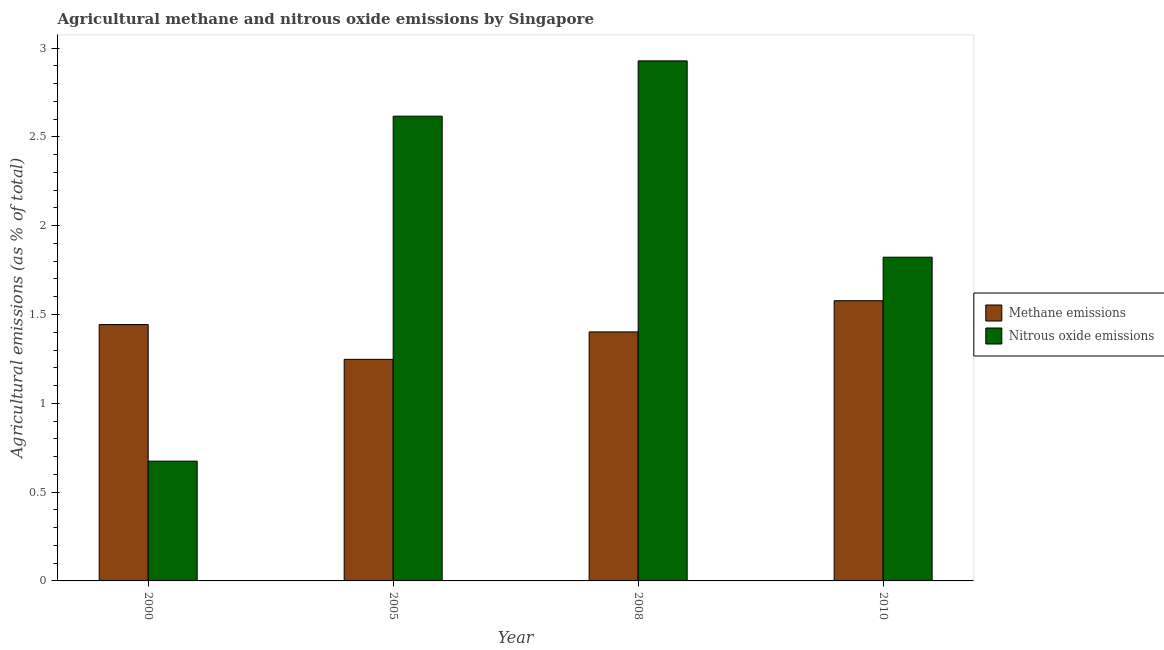How many different coloured bars are there?
Ensure brevity in your answer.  2. Are the number of bars per tick equal to the number of legend labels?
Give a very brief answer. Yes. How many bars are there on the 3rd tick from the right?
Offer a very short reply. 2. What is the label of the 4th group of bars from the left?
Offer a very short reply. 2010. What is the amount of methane emissions in 2000?
Ensure brevity in your answer.  1.44. Across all years, what is the maximum amount of nitrous oxide emissions?
Your answer should be compact. 2.93. Across all years, what is the minimum amount of nitrous oxide emissions?
Make the answer very short. 0.67. In which year was the amount of nitrous oxide emissions maximum?
Ensure brevity in your answer.  2008. What is the total amount of nitrous oxide emissions in the graph?
Give a very brief answer. 8.04. What is the difference between the amount of nitrous oxide emissions in 2008 and that in 2010?
Give a very brief answer. 1.11. What is the difference between the amount of nitrous oxide emissions in 2008 and the amount of methane emissions in 2010?
Ensure brevity in your answer.  1.11. What is the average amount of nitrous oxide emissions per year?
Offer a very short reply. 2.01. In the year 2000, what is the difference between the amount of methane emissions and amount of nitrous oxide emissions?
Offer a very short reply. 0. In how many years, is the amount of nitrous oxide emissions greater than 0.8 %?
Ensure brevity in your answer.  3. What is the ratio of the amount of methane emissions in 2005 to that in 2010?
Offer a terse response. 0.79. Is the difference between the amount of methane emissions in 2000 and 2005 greater than the difference between the amount of nitrous oxide emissions in 2000 and 2005?
Your answer should be very brief. No. What is the difference between the highest and the second highest amount of nitrous oxide emissions?
Keep it short and to the point. 0.31. What is the difference between the highest and the lowest amount of methane emissions?
Make the answer very short. 0.33. Is the sum of the amount of methane emissions in 2005 and 2008 greater than the maximum amount of nitrous oxide emissions across all years?
Provide a short and direct response. Yes. What does the 2nd bar from the left in 2005 represents?
Provide a succinct answer. Nitrous oxide emissions. What does the 2nd bar from the right in 2000 represents?
Provide a short and direct response. Methane emissions. How many bars are there?
Give a very brief answer. 8. How many years are there in the graph?
Provide a succinct answer. 4. What is the difference between two consecutive major ticks on the Y-axis?
Your answer should be very brief. 0.5. Are the values on the major ticks of Y-axis written in scientific E-notation?
Ensure brevity in your answer.  No. Where does the legend appear in the graph?
Offer a very short reply. Center right. What is the title of the graph?
Make the answer very short. Agricultural methane and nitrous oxide emissions by Singapore. Does "Birth rate" appear as one of the legend labels in the graph?
Keep it short and to the point. No. What is the label or title of the X-axis?
Ensure brevity in your answer.  Year. What is the label or title of the Y-axis?
Your answer should be compact. Agricultural emissions (as % of total). What is the Agricultural emissions (as % of total) in Methane emissions in 2000?
Ensure brevity in your answer.  1.44. What is the Agricultural emissions (as % of total) in Nitrous oxide emissions in 2000?
Give a very brief answer. 0.67. What is the Agricultural emissions (as % of total) of Methane emissions in 2005?
Your answer should be compact. 1.25. What is the Agricultural emissions (as % of total) of Nitrous oxide emissions in 2005?
Make the answer very short. 2.62. What is the Agricultural emissions (as % of total) of Methane emissions in 2008?
Keep it short and to the point. 1.4. What is the Agricultural emissions (as % of total) in Nitrous oxide emissions in 2008?
Your answer should be compact. 2.93. What is the Agricultural emissions (as % of total) in Methane emissions in 2010?
Your answer should be compact. 1.58. What is the Agricultural emissions (as % of total) in Nitrous oxide emissions in 2010?
Your answer should be very brief. 1.82. Across all years, what is the maximum Agricultural emissions (as % of total) of Methane emissions?
Your answer should be very brief. 1.58. Across all years, what is the maximum Agricultural emissions (as % of total) of Nitrous oxide emissions?
Your answer should be compact. 2.93. Across all years, what is the minimum Agricultural emissions (as % of total) of Methane emissions?
Your answer should be compact. 1.25. Across all years, what is the minimum Agricultural emissions (as % of total) in Nitrous oxide emissions?
Give a very brief answer. 0.67. What is the total Agricultural emissions (as % of total) in Methane emissions in the graph?
Your answer should be compact. 5.67. What is the total Agricultural emissions (as % of total) of Nitrous oxide emissions in the graph?
Offer a very short reply. 8.04. What is the difference between the Agricultural emissions (as % of total) of Methane emissions in 2000 and that in 2005?
Your response must be concise. 0.2. What is the difference between the Agricultural emissions (as % of total) in Nitrous oxide emissions in 2000 and that in 2005?
Your response must be concise. -1.94. What is the difference between the Agricultural emissions (as % of total) in Methane emissions in 2000 and that in 2008?
Your response must be concise. 0.04. What is the difference between the Agricultural emissions (as % of total) in Nitrous oxide emissions in 2000 and that in 2008?
Provide a succinct answer. -2.25. What is the difference between the Agricultural emissions (as % of total) in Methane emissions in 2000 and that in 2010?
Give a very brief answer. -0.13. What is the difference between the Agricultural emissions (as % of total) in Nitrous oxide emissions in 2000 and that in 2010?
Provide a succinct answer. -1.15. What is the difference between the Agricultural emissions (as % of total) of Methane emissions in 2005 and that in 2008?
Make the answer very short. -0.15. What is the difference between the Agricultural emissions (as % of total) of Nitrous oxide emissions in 2005 and that in 2008?
Make the answer very short. -0.31. What is the difference between the Agricultural emissions (as % of total) of Methane emissions in 2005 and that in 2010?
Your answer should be very brief. -0.33. What is the difference between the Agricultural emissions (as % of total) of Nitrous oxide emissions in 2005 and that in 2010?
Your answer should be very brief. 0.79. What is the difference between the Agricultural emissions (as % of total) in Methane emissions in 2008 and that in 2010?
Give a very brief answer. -0.18. What is the difference between the Agricultural emissions (as % of total) of Nitrous oxide emissions in 2008 and that in 2010?
Give a very brief answer. 1.11. What is the difference between the Agricultural emissions (as % of total) of Methane emissions in 2000 and the Agricultural emissions (as % of total) of Nitrous oxide emissions in 2005?
Provide a succinct answer. -1.17. What is the difference between the Agricultural emissions (as % of total) of Methane emissions in 2000 and the Agricultural emissions (as % of total) of Nitrous oxide emissions in 2008?
Keep it short and to the point. -1.48. What is the difference between the Agricultural emissions (as % of total) of Methane emissions in 2000 and the Agricultural emissions (as % of total) of Nitrous oxide emissions in 2010?
Ensure brevity in your answer.  -0.38. What is the difference between the Agricultural emissions (as % of total) of Methane emissions in 2005 and the Agricultural emissions (as % of total) of Nitrous oxide emissions in 2008?
Ensure brevity in your answer.  -1.68. What is the difference between the Agricultural emissions (as % of total) in Methane emissions in 2005 and the Agricultural emissions (as % of total) in Nitrous oxide emissions in 2010?
Offer a terse response. -0.58. What is the difference between the Agricultural emissions (as % of total) of Methane emissions in 2008 and the Agricultural emissions (as % of total) of Nitrous oxide emissions in 2010?
Offer a very short reply. -0.42. What is the average Agricultural emissions (as % of total) in Methane emissions per year?
Offer a terse response. 1.42. What is the average Agricultural emissions (as % of total) in Nitrous oxide emissions per year?
Ensure brevity in your answer.  2.01. In the year 2000, what is the difference between the Agricultural emissions (as % of total) of Methane emissions and Agricultural emissions (as % of total) of Nitrous oxide emissions?
Make the answer very short. 0.77. In the year 2005, what is the difference between the Agricultural emissions (as % of total) in Methane emissions and Agricultural emissions (as % of total) in Nitrous oxide emissions?
Your response must be concise. -1.37. In the year 2008, what is the difference between the Agricultural emissions (as % of total) of Methane emissions and Agricultural emissions (as % of total) of Nitrous oxide emissions?
Your answer should be very brief. -1.53. In the year 2010, what is the difference between the Agricultural emissions (as % of total) in Methane emissions and Agricultural emissions (as % of total) in Nitrous oxide emissions?
Your response must be concise. -0.24. What is the ratio of the Agricultural emissions (as % of total) in Methane emissions in 2000 to that in 2005?
Offer a terse response. 1.16. What is the ratio of the Agricultural emissions (as % of total) in Nitrous oxide emissions in 2000 to that in 2005?
Offer a very short reply. 0.26. What is the ratio of the Agricultural emissions (as % of total) of Methane emissions in 2000 to that in 2008?
Make the answer very short. 1.03. What is the ratio of the Agricultural emissions (as % of total) of Nitrous oxide emissions in 2000 to that in 2008?
Give a very brief answer. 0.23. What is the ratio of the Agricultural emissions (as % of total) in Methane emissions in 2000 to that in 2010?
Offer a terse response. 0.91. What is the ratio of the Agricultural emissions (as % of total) in Nitrous oxide emissions in 2000 to that in 2010?
Give a very brief answer. 0.37. What is the ratio of the Agricultural emissions (as % of total) in Methane emissions in 2005 to that in 2008?
Offer a very short reply. 0.89. What is the ratio of the Agricultural emissions (as % of total) of Nitrous oxide emissions in 2005 to that in 2008?
Provide a short and direct response. 0.89. What is the ratio of the Agricultural emissions (as % of total) of Methane emissions in 2005 to that in 2010?
Provide a succinct answer. 0.79. What is the ratio of the Agricultural emissions (as % of total) of Nitrous oxide emissions in 2005 to that in 2010?
Give a very brief answer. 1.44. What is the ratio of the Agricultural emissions (as % of total) of Methane emissions in 2008 to that in 2010?
Your answer should be very brief. 0.89. What is the ratio of the Agricultural emissions (as % of total) in Nitrous oxide emissions in 2008 to that in 2010?
Your response must be concise. 1.61. What is the difference between the highest and the second highest Agricultural emissions (as % of total) in Methane emissions?
Offer a very short reply. 0.13. What is the difference between the highest and the second highest Agricultural emissions (as % of total) in Nitrous oxide emissions?
Your answer should be very brief. 0.31. What is the difference between the highest and the lowest Agricultural emissions (as % of total) in Methane emissions?
Make the answer very short. 0.33. What is the difference between the highest and the lowest Agricultural emissions (as % of total) in Nitrous oxide emissions?
Your answer should be very brief. 2.25. 